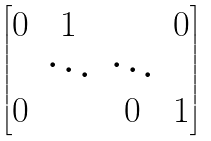Convert formula to latex. <formula><loc_0><loc_0><loc_500><loc_500>\begin{bmatrix} 0 & 1 & & 0 \\ & \ddots & \ddots & \\ 0 & & 0 & 1 \end{bmatrix}</formula> 